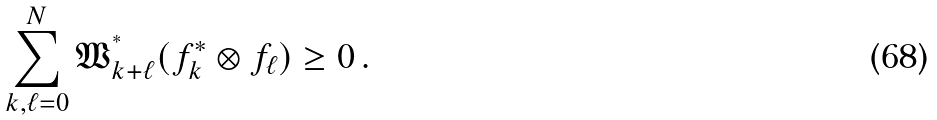Convert formula to latex. <formula><loc_0><loc_0><loc_500><loc_500>\sum _ { k , \ell = 0 } ^ { N } { \mathfrak W } ^ { ^ { * } } _ { k + \ell } ( f _ { k } ^ { * } \otimes f _ { \ell } ) \geq 0 \, .</formula> 